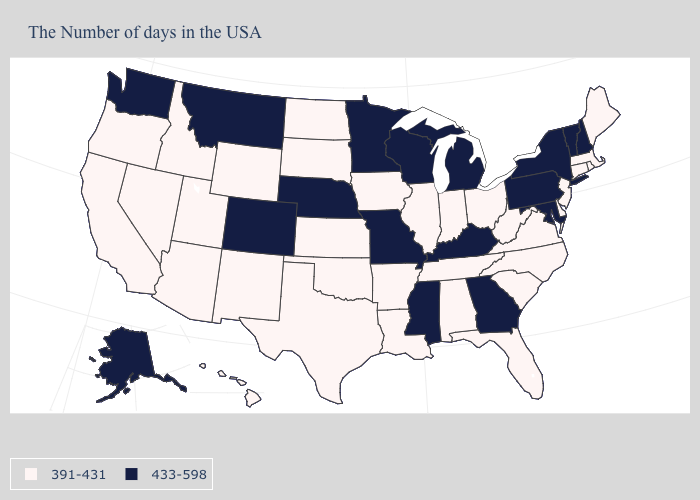Does the map have missing data?
Give a very brief answer. No. Among the states that border Pennsylvania , which have the lowest value?
Give a very brief answer. New Jersey, Delaware, West Virginia, Ohio. Does Delaware have a lower value than Minnesota?
Quick response, please. Yes. Which states hav the highest value in the West?
Be succinct. Colorado, Montana, Washington, Alaska. Name the states that have a value in the range 433-598?
Short answer required. New Hampshire, Vermont, New York, Maryland, Pennsylvania, Georgia, Michigan, Kentucky, Wisconsin, Mississippi, Missouri, Minnesota, Nebraska, Colorado, Montana, Washington, Alaska. Which states hav the highest value in the West?
Write a very short answer. Colorado, Montana, Washington, Alaska. Name the states that have a value in the range 433-598?
Short answer required. New Hampshire, Vermont, New York, Maryland, Pennsylvania, Georgia, Michigan, Kentucky, Wisconsin, Mississippi, Missouri, Minnesota, Nebraska, Colorado, Montana, Washington, Alaska. Name the states that have a value in the range 391-431?
Give a very brief answer. Maine, Massachusetts, Rhode Island, Connecticut, New Jersey, Delaware, Virginia, North Carolina, South Carolina, West Virginia, Ohio, Florida, Indiana, Alabama, Tennessee, Illinois, Louisiana, Arkansas, Iowa, Kansas, Oklahoma, Texas, South Dakota, North Dakota, Wyoming, New Mexico, Utah, Arizona, Idaho, Nevada, California, Oregon, Hawaii. What is the value of Mississippi?
Keep it brief. 433-598. Name the states that have a value in the range 433-598?
Keep it brief. New Hampshire, Vermont, New York, Maryland, Pennsylvania, Georgia, Michigan, Kentucky, Wisconsin, Mississippi, Missouri, Minnesota, Nebraska, Colorado, Montana, Washington, Alaska. Name the states that have a value in the range 391-431?
Keep it brief. Maine, Massachusetts, Rhode Island, Connecticut, New Jersey, Delaware, Virginia, North Carolina, South Carolina, West Virginia, Ohio, Florida, Indiana, Alabama, Tennessee, Illinois, Louisiana, Arkansas, Iowa, Kansas, Oklahoma, Texas, South Dakota, North Dakota, Wyoming, New Mexico, Utah, Arizona, Idaho, Nevada, California, Oregon, Hawaii. What is the value of Rhode Island?
Short answer required. 391-431. What is the highest value in states that border Maine?
Keep it brief. 433-598. Among the states that border Connecticut , does New York have the lowest value?
Write a very short answer. No. Is the legend a continuous bar?
Short answer required. No. 